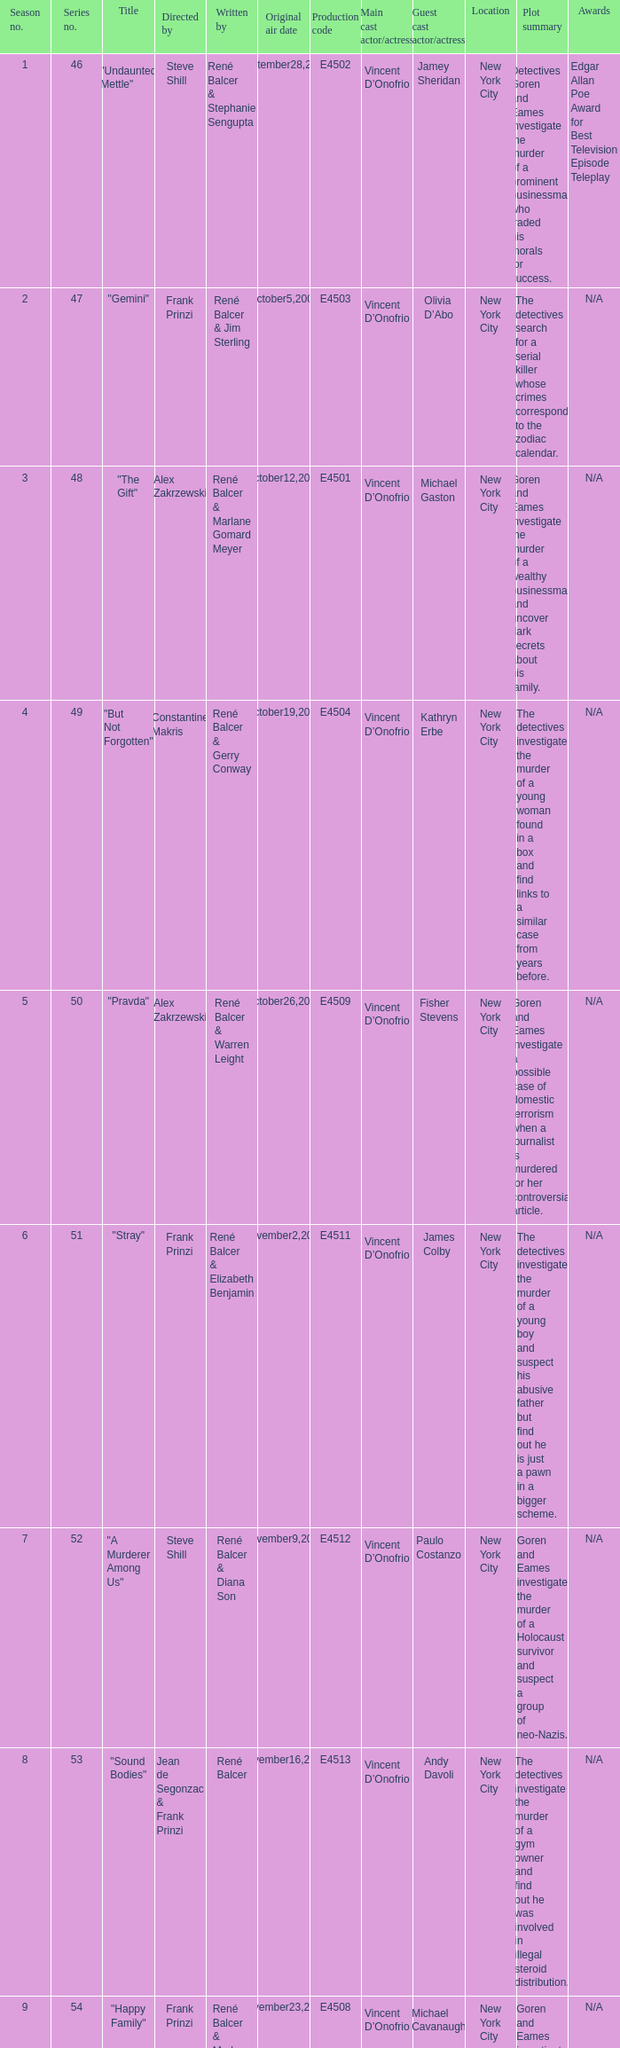Help me parse the entirety of this table. {'header': ['Season no.', 'Series no.', 'Title', 'Directed by', 'Written by', 'Original air date', 'Production code', 'Main cast actor/actress', 'Guest cast actor/actress', 'Location', 'Plot summary', 'Awards'], 'rows': [['1', '46', '"Undaunted Mettle"', 'Steve Shill', 'René Balcer & Stephanie Sengupta', 'September28,2003', 'E4502', 'Vincent D’Onofrio', 'Jamey Sheridan', 'New York City', 'Detectives Goren and Eames investigate the murder of a prominent businessman who traded his morals for success.', 'Edgar Allan Poe Award for Best Television Episode Teleplay'], ['2', '47', '"Gemini"', 'Frank Prinzi', 'René Balcer & Jim Sterling', 'October5,2003', 'E4503', 'Vincent D’Onofrio', 'Olivia D’Abo', 'New York City', 'The detectives search for a serial killer whose crimes correspond to the zodiac calendar.', 'N/A'], ['3', '48', '"The Gift"', 'Alex Zakrzewski', 'René Balcer & Marlane Gomard Meyer', 'October12,2003', 'E4501', 'Vincent D’Onofrio', 'Michael Gaston', 'New York City', 'Goren and Eames investigate the murder of a wealthy businessman and uncover dark secrets about his family.', 'N/A'], ['4', '49', '"But Not Forgotten"', 'Constantine Makris', 'René Balcer & Gerry Conway', 'October19,2003', 'E4504', 'Vincent D’Onofrio', 'Kathryn Erbe', 'New York City', 'The detectives investigate the murder of a young woman found in a box and find links to a similar case from years before.', 'N/A'], ['5', '50', '"Pravda"', 'Alex Zakrzewski', 'René Balcer & Warren Leight', 'October26,2003', 'E4509', 'Vincent D’Onofrio', 'Fisher Stevens', 'New York City', 'Goren and Eames investigate a possible case of domestic terrorism when a journalist is murdered for her controversial article.', 'N/A'], ['6', '51', '"Stray"', 'Frank Prinzi', 'René Balcer & Elizabeth Benjamin', 'November2,2003', 'E4511', 'Vincent D’Onofrio', 'James Colby', 'New York City', 'The detectives investigate the murder of a young boy and suspect his abusive father but find out he is just a pawn in a bigger scheme.', 'N/A'], ['7', '52', '"A Murderer Among Us"', 'Steve Shill', 'René Balcer & Diana Son', 'November9,2003', 'E4512', 'Vincent D’Onofrio', 'Paulo Costanzo', 'New York City', 'Goren and Eames investigate the murder of a Holocaust survivor and suspect a group of neo-Nazis.', 'N/A'], ['8', '53', '"Sound Bodies"', 'Jean de Segonzac & Frank Prinzi', 'René Balcer', 'November16,2003', 'E4513', 'Vincent D’Onofrio', 'Andy Davoli', 'New York City', 'The detectives investigate the murder of a gym owner and find out he was involved in illegal steroid distribution.', 'N/A'], ['9', '54', '"Happy Family"', 'Frank Prinzi', 'René Balcer & Marlane Gomard Meyer', 'November23,2003', 'E4508', 'Vincent D’Onofrio', 'Michael Cavanaugh', 'New York City', 'Goren and Eames investigate the murder of a woman found in a hotel room with her family and discover a twisted family dynamic.', 'N/A'], ['10', '55', '"F.P.S."', 'Darnell Martin', 'René Balcer & Gerry Conway', 'January4,2004', 'E4506', 'Vincent D’Onofrio', 'Michael Bloomberg', 'New York City', 'The detectives investigate the murder of a video game designer and find out the motive is linked to his work.', 'N/A'], ['11', '56', '"Mad Hops"', 'Christopher Swartout', 'René Balcer & Jim Sterling', 'January11,2004', 'E4514', 'Vincent D’Onofrio', 'Anthony Mackie', 'New York City', 'Goren and Eames investigate the murder of a college basketball star and find out he was involved in illegal gambling.', 'N/A'], ['12', '57', '"Unrequited"', 'Jean de Segonzac', 'René Balcer & Stephanie Sengupta', 'January18,2004', 'E4507', 'Vincent D’Onofrio', 'Kate Burton', 'New York City', 'The detectives investigate the murder of a teenage girl and become emotionally invested in the case.', 'N/A'], ['13', '58', '"Pas de Deux"', 'Frank Prinzi', 'René Balcer & Warren Leight', 'February15,2004', 'E4516', 'Vincent D’Onofrio', 'Melissa Leo', 'New York City', 'Goren and Eames investigate the murder of a ballet dancer and suspect her rival but the motive is more complicated.', 'N/A'], ['14', '59', '"Mis-Labeled"', 'Joyce Chopra', 'René Balcer & Elizabeth Benjamin', 'February22,2004', 'E4515', 'Vincent D’Onofrio', 'David Harbour', 'New York City', 'The detectives investigate the murder of a pharmacist and uncover a prescription drug ring.', 'N/A'], ['15', '60', '"Shrink-Wrapped"', 'Jean de Segonzac', 'René Balcer & Diana Son', 'March7,2004', 'E4510', 'Vincent D’Onofrio', 'Lili Taylor', 'New York City', 'Goren and Eames investigate the murder of a psychiatrist and suspect one of his patients but the motive is unexpected.', 'N/A'], ['16', '61', '"The Saint"', 'Frank Prinzi', 'René Balcer & Marlane Gomard Meyer', 'March14,2004', 'E4517', 'Vincent D’Onofrio', 'Joe Morton', 'New York City', 'The detectives investigate the murder of a Nigerian man and become tangled in international politics.', 'N/A'], ['17', '62', '"Conscience"', 'Alex Chapple', 'René Balcer & Gerry Conway', 'March28,2004', 'E4519', 'Vincent D’Onofrio', 'Marley Shelton', 'New York City', 'Goren and Eames investigate the murder of a celebrity chef and suspect his protege but the motive is personal.', 'N/A'], ['18', '63', '"Ill-Bred"', 'Steve Shill', 'René Balcer & Jim Sterling', 'April18,2004', 'E4520', 'Vincent D’Onofrio', 'James Badge Dale', 'New York City', 'The detectives investigate the murder of a socialite and suspect her husband but the motive is hidden in her past.', 'N/A'], ['19', '64', '"Fico di Capo"', 'Alex Zakrzewski', 'René Balcer & Stephanie Sengupta', 'May9,2004', 'E4518', 'Vincent D’Onofrio', 'Susan Misner', 'New York City', 'Goren and Eames investigate the murder of a noted wine connoisseur and find out the motive is linked to his connection to the mob.', 'N/A'], ['20', '65', '"D.A.W."', 'Frank Prinzi', 'René Balcer & Warren Leight', 'May16,2004', 'E4522', 'Vincent D’Onofrio', 'Jennifer Esposito', 'New York City', 'The detectives investigate the murder of a businesswoman and find out the motive is related to her shady business dealings.', 'N/A']]} Who wrote the episode with e4515 as the production code? René Balcer & Elizabeth Benjamin. 